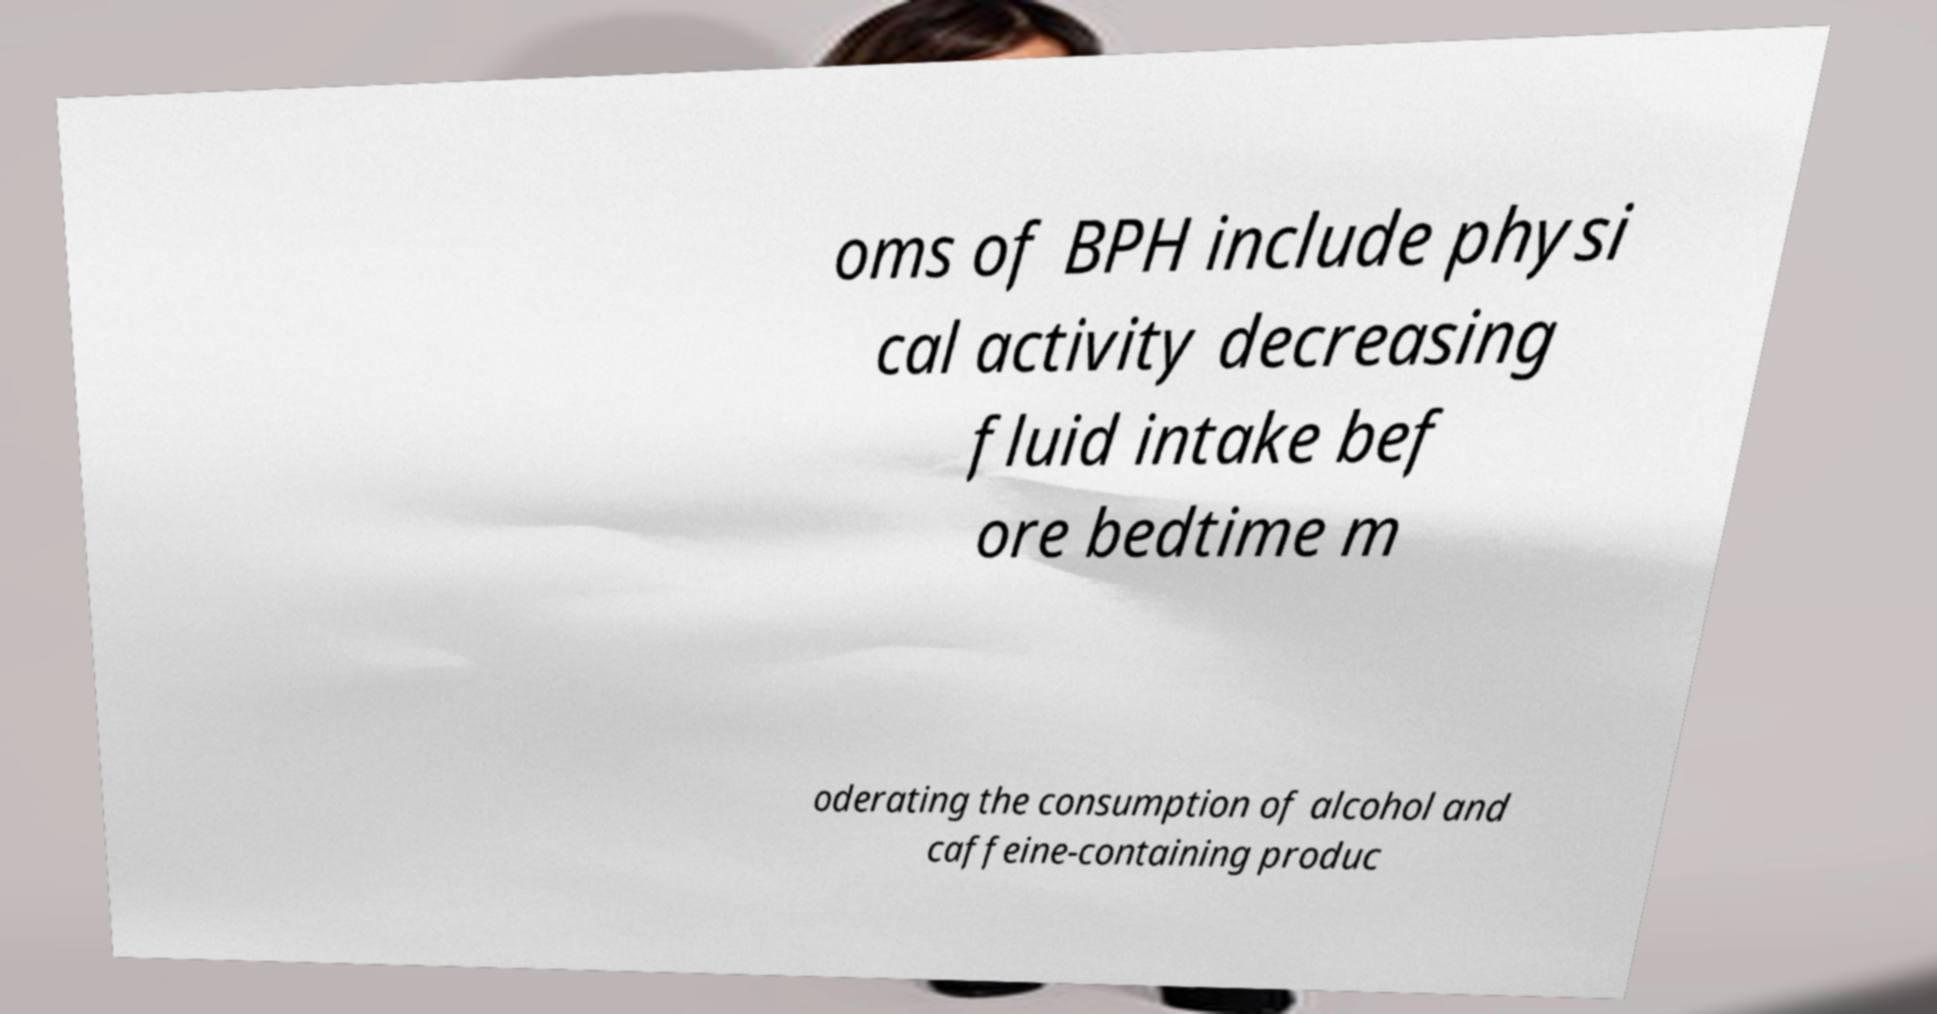I need the written content from this picture converted into text. Can you do that? oms of BPH include physi cal activity decreasing fluid intake bef ore bedtime m oderating the consumption of alcohol and caffeine-containing produc 